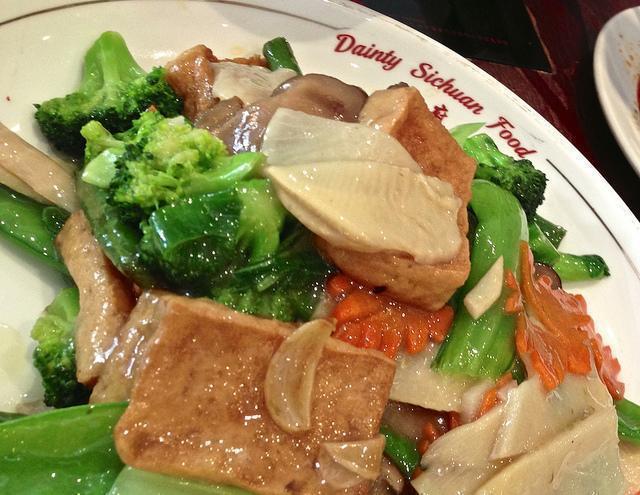What kind of cuisine is being served?
Choose the right answer from the provided options to respond to the question.
Options: Chinese, korean, indian, japanese. Chinese. 